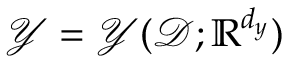Convert formula to latex. <formula><loc_0><loc_0><loc_500><loc_500>\mathcal { Y } = \mathcal { Y } ( \mathcal { D } ; \mathbb { R } ^ { d _ { y } } )</formula> 